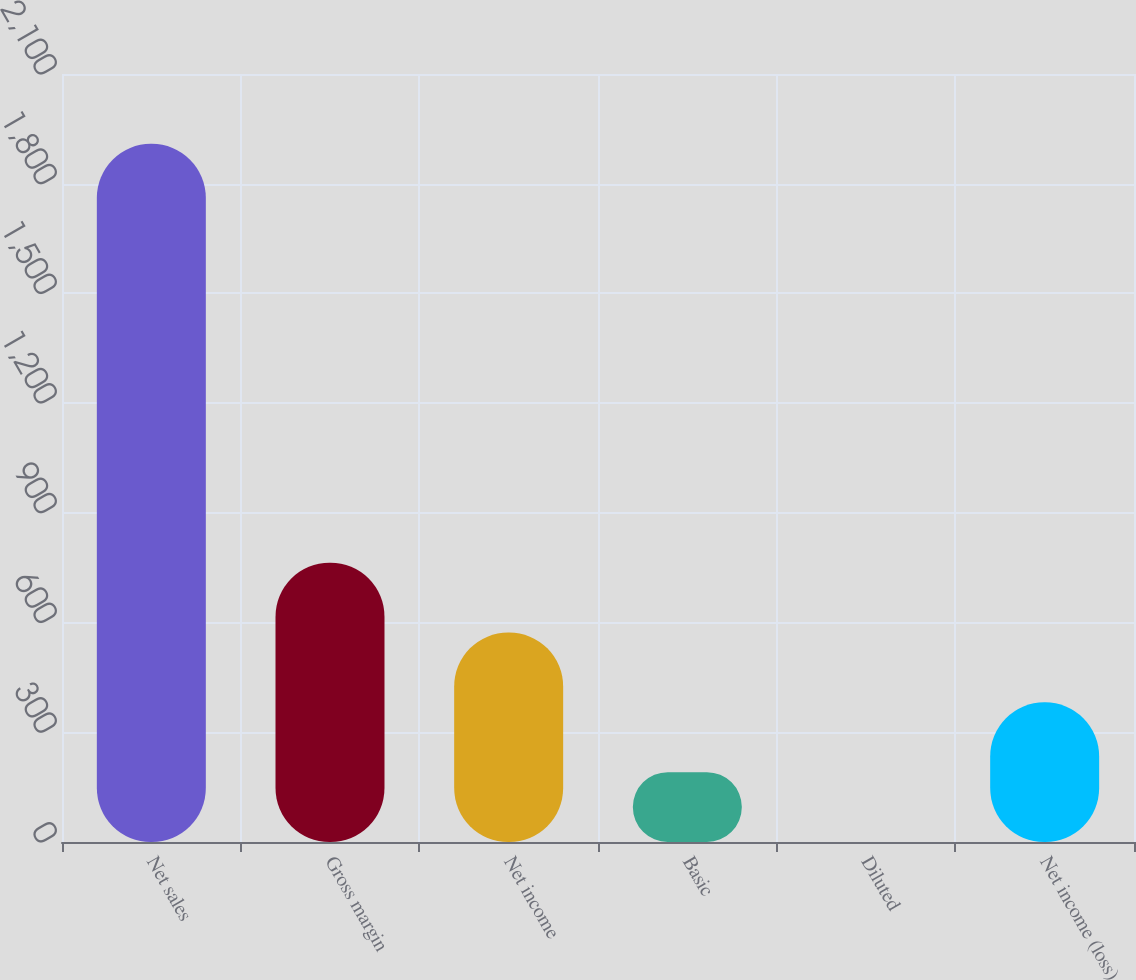Convert chart. <chart><loc_0><loc_0><loc_500><loc_500><bar_chart><fcel>Net sales<fcel>Gross margin<fcel>Net income<fcel>Basic<fcel>Diluted<fcel>Net income (loss)<nl><fcel>1909<fcel>763.68<fcel>572.79<fcel>191.01<fcel>0.12<fcel>381.9<nl></chart> 